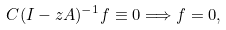Convert formula to latex. <formula><loc_0><loc_0><loc_500><loc_500>C ( I - z A ) ^ { - 1 } f \equiv 0 \Longrightarrow f = 0 ,</formula> 